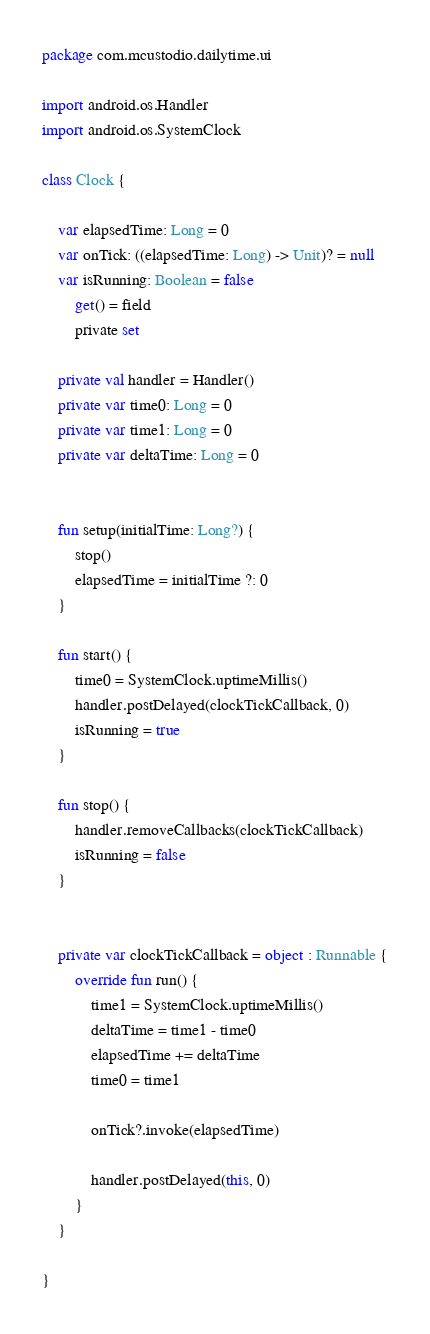<code> <loc_0><loc_0><loc_500><loc_500><_Kotlin_>package com.mcustodio.dailytime.ui

import android.os.Handler
import android.os.SystemClock

class Clock {

    var elapsedTime: Long = 0
    var onTick: ((elapsedTime: Long) -> Unit)? = null
    var isRunning: Boolean = false
        get() = field
        private set

    private val handler = Handler()
    private var time0: Long = 0
    private var time1: Long = 0
    private var deltaTime: Long = 0


    fun setup(initialTime: Long?) {
        stop()
        elapsedTime = initialTime ?: 0
    }

    fun start() {
        time0 = SystemClock.uptimeMillis()
        handler.postDelayed(clockTickCallback, 0)
        isRunning = true
    }

    fun stop() {
        handler.removeCallbacks(clockTickCallback)
        isRunning = false
    }


    private var clockTickCallback = object : Runnable {
        override fun run() {
            time1 = SystemClock.uptimeMillis()
            deltaTime = time1 - time0
            elapsedTime += deltaTime
            time0 = time1

            onTick?.invoke(elapsedTime)

            handler.postDelayed(this, 0)
        }
    }

}</code> 